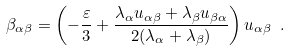Convert formula to latex. <formula><loc_0><loc_0><loc_500><loc_500>\beta _ { \alpha \beta } = \left ( - \frac { \varepsilon } { 3 } + \frac { \lambda _ { \alpha } u _ { \alpha \beta } + \lambda _ { \beta } u _ { \beta \alpha } } { 2 ( \lambda _ { \alpha } + \lambda _ { \beta } ) } \right ) u _ { \alpha \beta } \ .</formula> 